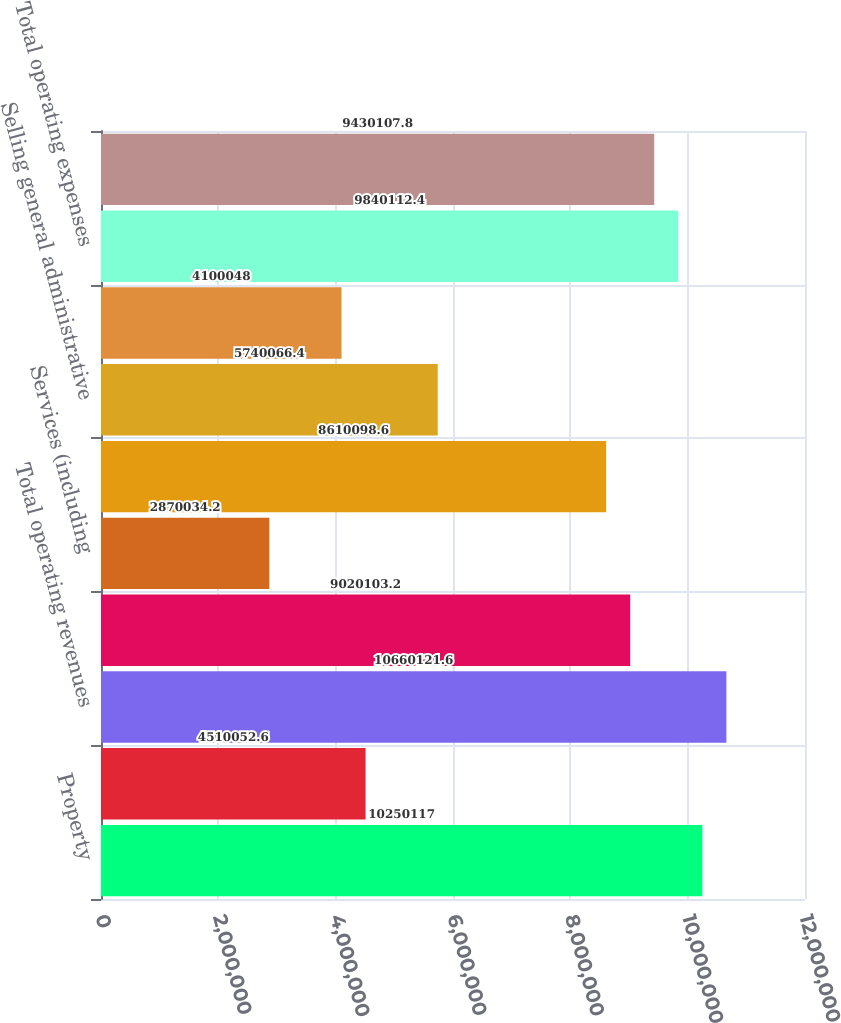Convert chart to OTSL. <chart><loc_0><loc_0><loc_500><loc_500><bar_chart><fcel>Property<fcel>Services<fcel>Total operating revenues<fcel>Property (including<fcel>Services (including<fcel>Depreciation amortization and<fcel>Selling general administrative<fcel>Other operating expenses<fcel>Total operating expenses<fcel>OPERATING INCOME<nl><fcel>1.02501e+07<fcel>4.51005e+06<fcel>1.06601e+07<fcel>9.0201e+06<fcel>2.87003e+06<fcel>8.6101e+06<fcel>5.74007e+06<fcel>4.10005e+06<fcel>9.84011e+06<fcel>9.43011e+06<nl></chart> 